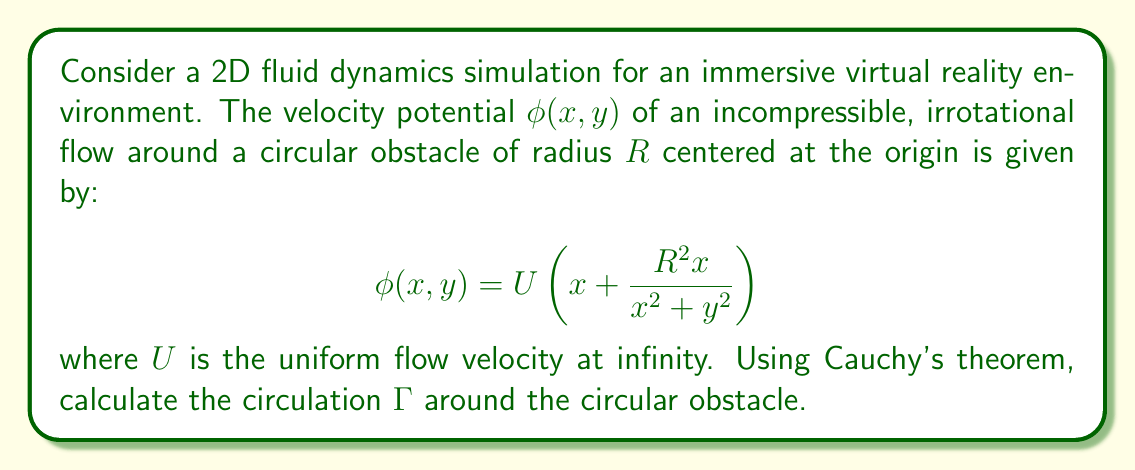Can you answer this question? To solve this problem, we'll follow these steps:

1) First, recall that the circulation $\Gamma$ is defined as the line integral of velocity around a closed contour:

   $$\Gamma = \oint_C \mathbf{v} \cdot d\mathbf{l}$$

   where $\mathbf{v}$ is the velocity vector and $d\mathbf{l}$ is the differential line element.

2) For an irrotational flow, we can express velocity in terms of the velocity potential:

   $$\mathbf{v} = \nabla\phi = \left(\frac{\partial\phi}{\partial x}, \frac{\partial\phi}{\partial y}\right)$$

3) Calculate the partial derivatives:

   $$\frac{\partial\phi}{\partial x} = U\left(1 + \frac{R^2(y^2-x^2)}{(x^2+y^2)^2}\right)$$
   $$\frac{\partial\phi}{\partial y} = -\frac{2UR^2xy}{(x^2+y^2)^2}$$

4) Now, we can express the circulation as a complex contour integral:

   $$\Gamma = \oint_C (u-iv)dz = \oint_C \left(\frac{\partial\phi}{\partial x} - i\frac{\partial\phi}{\partial y}\right)dz$$

   where $z = x + iy$.

5) Substitute the expressions for the partial derivatives:

   $$\Gamma = \oint_C \left[U\left(1 + \frac{R^2(y^2-x^2)}{(x^2+y^2)^2}\right) + i\frac{2UR^2xy}{(x^2+y^2)^2}\right]dz$$

6) Observe that this integrand is analytic everywhere except at $z=0$. The circular obstacle forms a simple closed contour around this singularity.

7) Apply Cauchy's theorem, which states that the contour integral of an analytic function around a simple closed contour is zero. Since our integrand is not analytic at $z=0$, the integral will be $2\pi i$ times the residue at this point.

8) To find the residue, we need to examine the behavior of the integrand as $z$ approaches 0. The term $U$ is constant, so it doesn't contribute to the residue. The remaining terms can be simplified:

   $$\frac{R^2(y^2-x^2)}{(x^2+y^2)^2} + i\frac{2R^2xy}{(x^2+y^2)^2} = \frac{R^2}{z\bar{z}}$$

9) The residue is therefore 0, as this term doesn't have a $\frac{1}{z}$ term in its Laurent series expansion around $z=0$.

10) Consequently, the circulation $\Gamma$ is zero.
Answer: $\Gamma = 0$ 